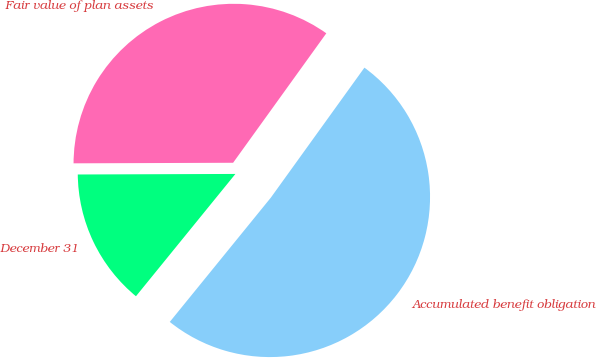<chart> <loc_0><loc_0><loc_500><loc_500><pie_chart><fcel>December 31<fcel>Accumulated benefit obligation<fcel>Fair value of plan assets<nl><fcel>14.08%<fcel>50.94%<fcel>34.99%<nl></chart> 